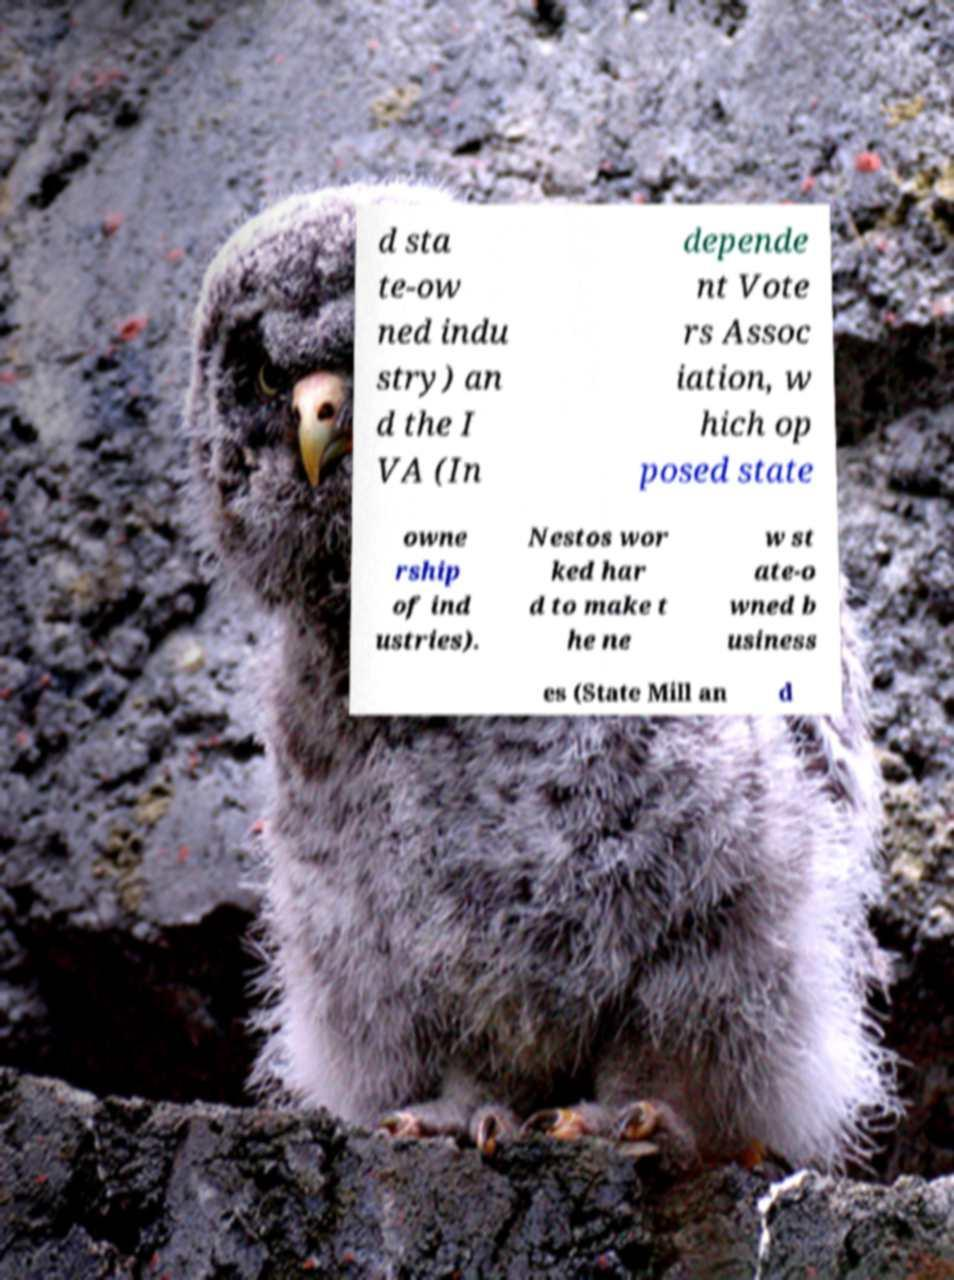Please read and relay the text visible in this image. What does it say? d sta te-ow ned indu stry) an d the I VA (In depende nt Vote rs Assoc iation, w hich op posed state owne rship of ind ustries). Nestos wor ked har d to make t he ne w st ate-o wned b usiness es (State Mill an d 